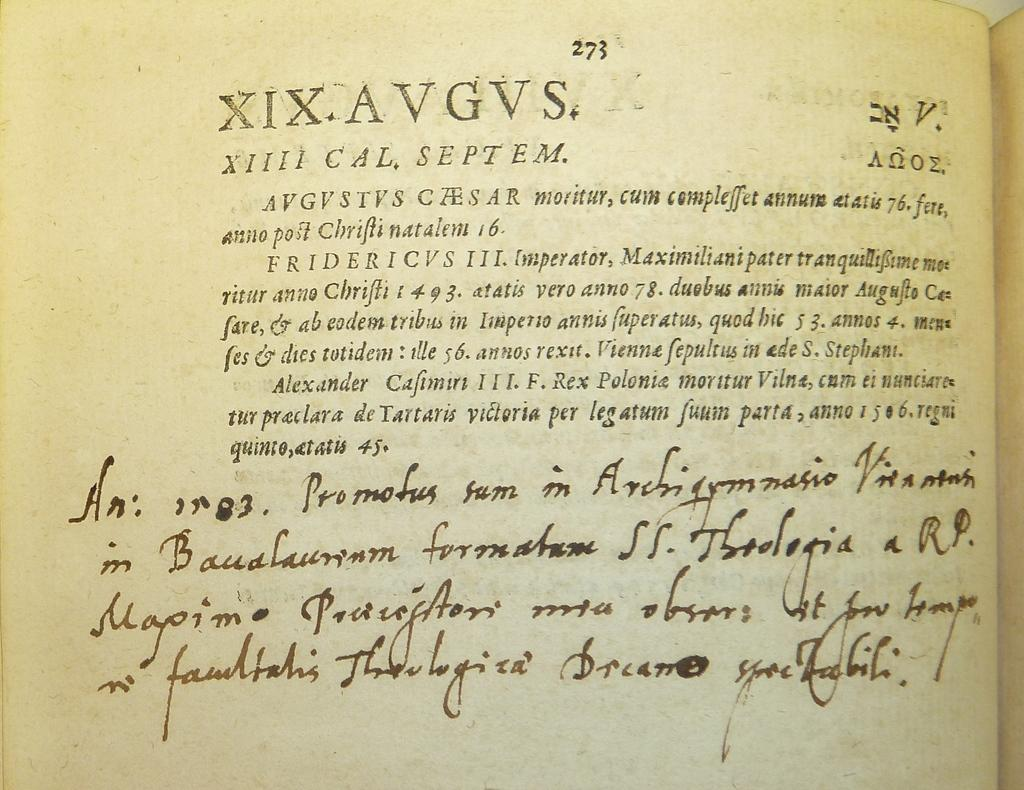What type of content is depicted on the page in the image? The image is a page from a book, and it appears to be from an article. Can you describe the layout or design of the page? Unfortunately, the provided facts do not give enough information to describe the layout or design of the page. What type of brake can be seen on the page in the image? There is no brake present on the page in the image; it is a page from a book with an article. What type of flesh is visible on the page in the image? There is no flesh present on the page in the image; it is a page from a book with an article. 